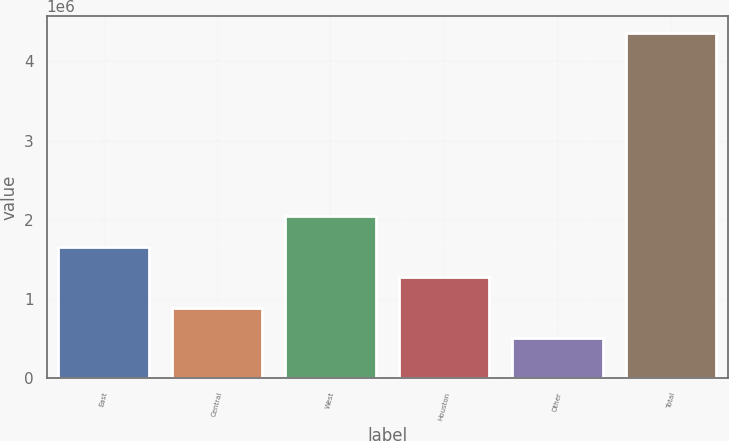Convert chart to OTSL. <chart><loc_0><loc_0><loc_500><loc_500><bar_chart><fcel>East<fcel>Central<fcel>West<fcel>Houston<fcel>Other<fcel>Total<nl><fcel>1.65961e+06<fcel>889428<fcel>2.0447e+06<fcel>1.27452e+06<fcel>504336<fcel>4.35525e+06<nl></chart> 